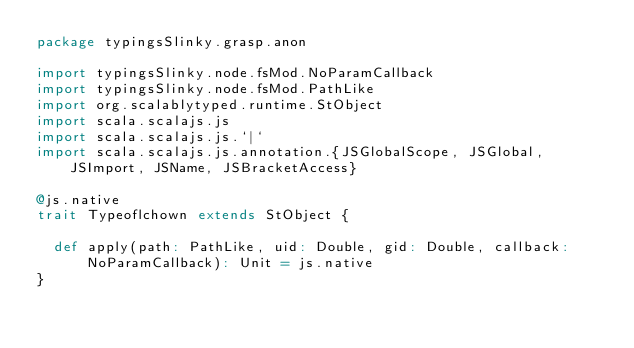Convert code to text. <code><loc_0><loc_0><loc_500><loc_500><_Scala_>package typingsSlinky.grasp.anon

import typingsSlinky.node.fsMod.NoParamCallback
import typingsSlinky.node.fsMod.PathLike
import org.scalablytyped.runtime.StObject
import scala.scalajs.js
import scala.scalajs.js.`|`
import scala.scalajs.js.annotation.{JSGlobalScope, JSGlobal, JSImport, JSName, JSBracketAccess}

@js.native
trait Typeoflchown extends StObject {
  
  def apply(path: PathLike, uid: Double, gid: Double, callback: NoParamCallback): Unit = js.native
}
</code> 